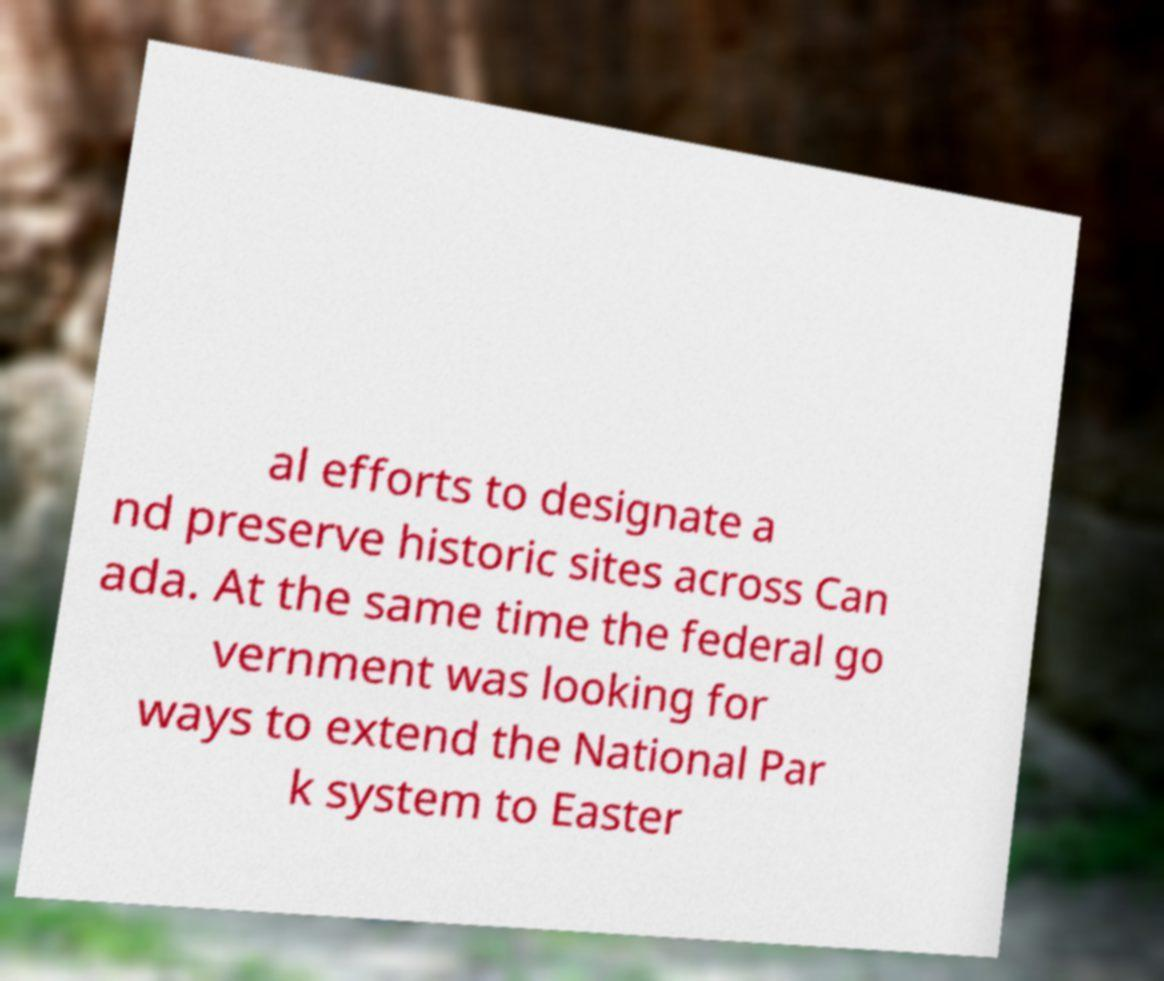Can you read and provide the text displayed in the image?This photo seems to have some interesting text. Can you extract and type it out for me? al efforts to designate a nd preserve historic sites across Can ada. At the same time the federal go vernment was looking for ways to extend the National Par k system to Easter 